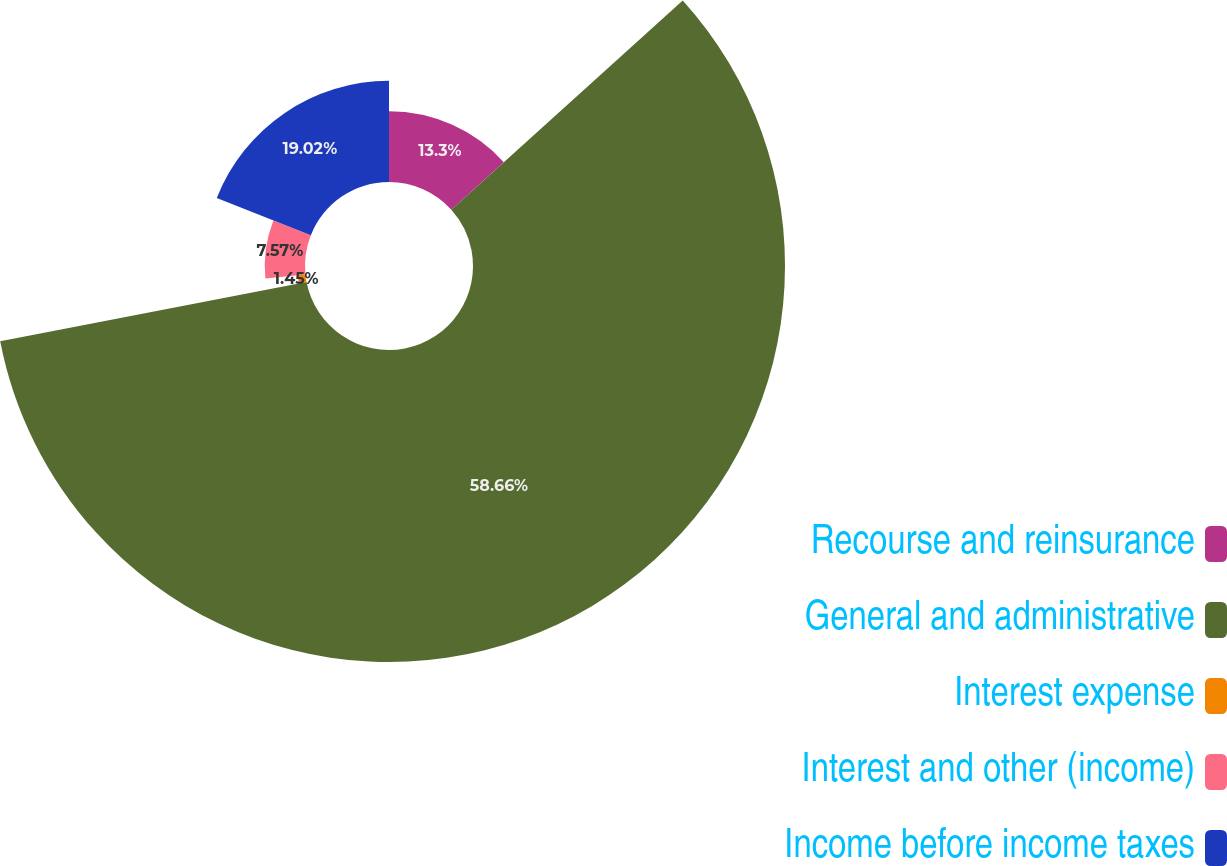Convert chart. <chart><loc_0><loc_0><loc_500><loc_500><pie_chart><fcel>Recourse and reinsurance<fcel>General and administrative<fcel>Interest expense<fcel>Interest and other (income)<fcel>Income before income taxes<nl><fcel>13.3%<fcel>58.66%<fcel>1.45%<fcel>7.57%<fcel>19.02%<nl></chart> 